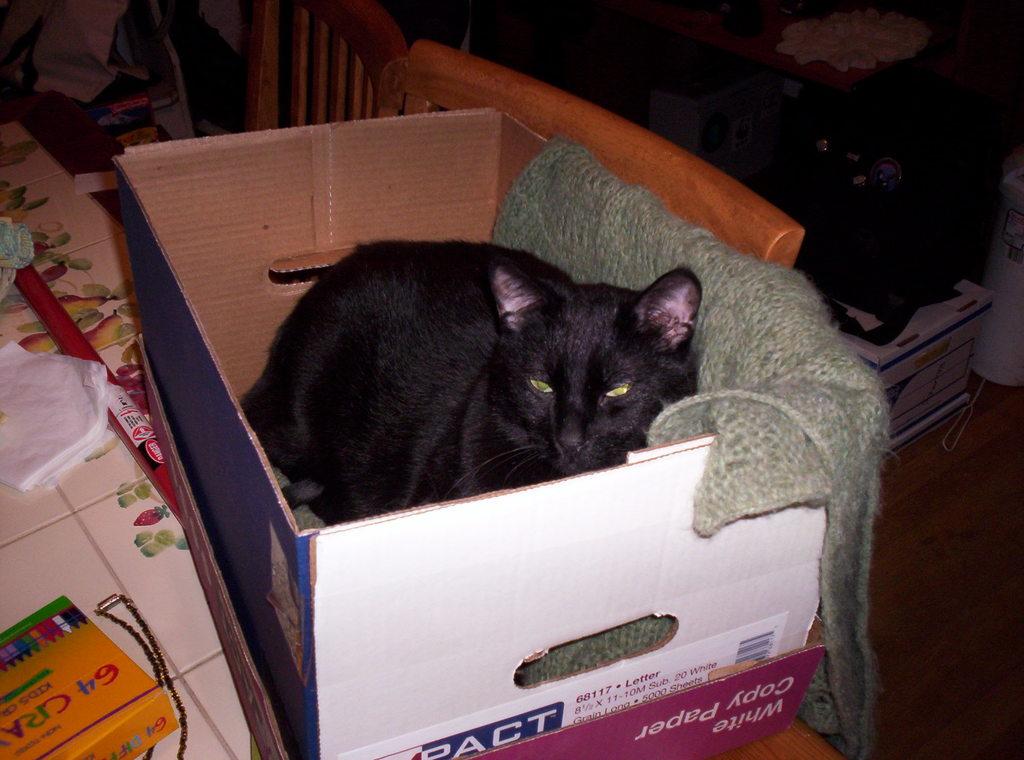What amount of crayons is on the crayon box?
Offer a terse response. 64. 